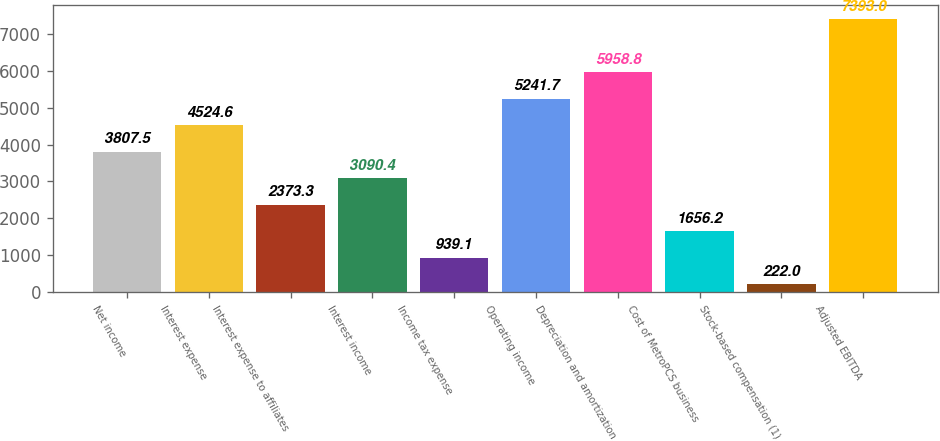<chart> <loc_0><loc_0><loc_500><loc_500><bar_chart><fcel>Net income<fcel>Interest expense<fcel>Interest expense to affiliates<fcel>Interest income<fcel>Income tax expense<fcel>Operating income<fcel>Depreciation and amortization<fcel>Cost of MetroPCS business<fcel>Stock-based compensation (1)<fcel>Adjusted EBITDA<nl><fcel>3807.5<fcel>4524.6<fcel>2373.3<fcel>3090.4<fcel>939.1<fcel>5241.7<fcel>5958.8<fcel>1656.2<fcel>222<fcel>7393<nl></chart> 